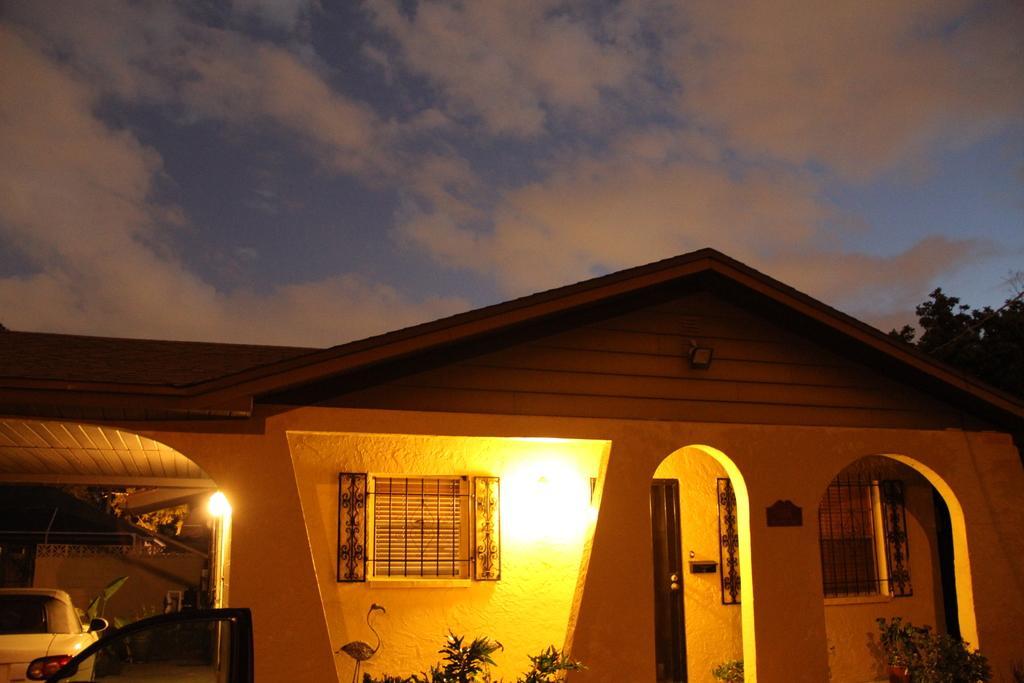Can you describe this image briefly? In the center of the image there is a house. There is a car. At the top of the image there is sky and clouds. There are trees. 